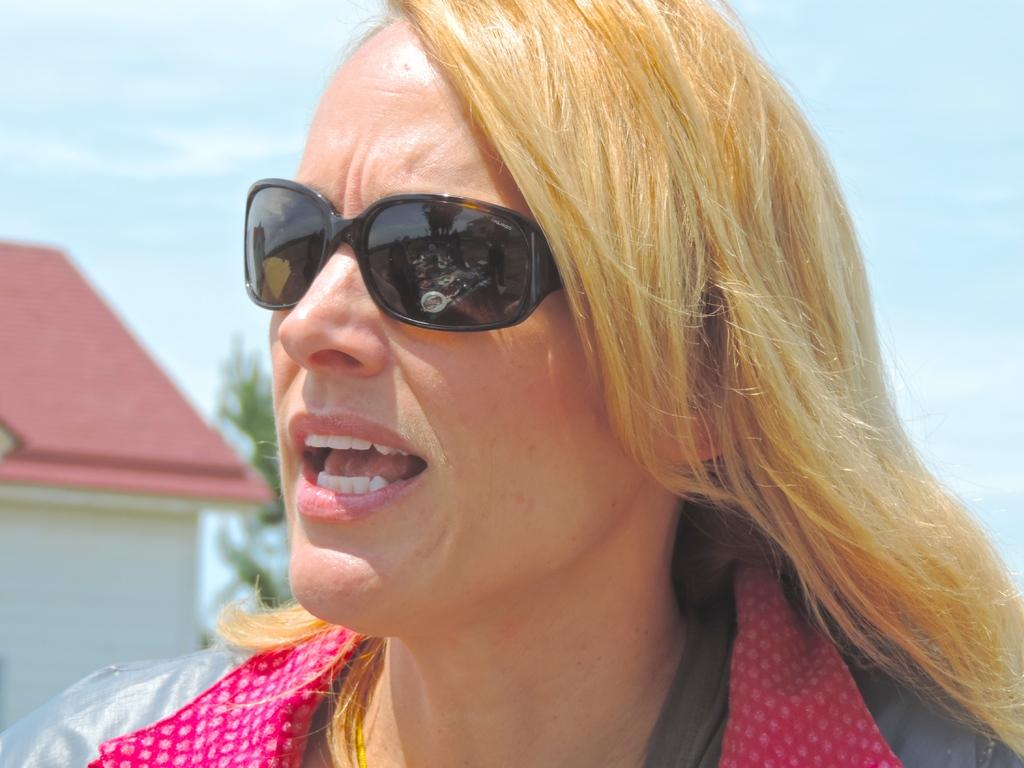Who is present in the image? There is a woman in the image. What is the woman wearing on her face? The woman is wearing goggles. What type of structure can be seen in the image? There is a house in the image. What type of plant is visible in the image? There is a tree in the image. What can be seen in the background of the image? The sky with clouds is visible in the background of the image. What type of quince is being used to build the house in the image? There is no quince present in the image, and it is not being used to build the house. 